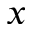Convert formula to latex. <formula><loc_0><loc_0><loc_500><loc_500>x</formula> 